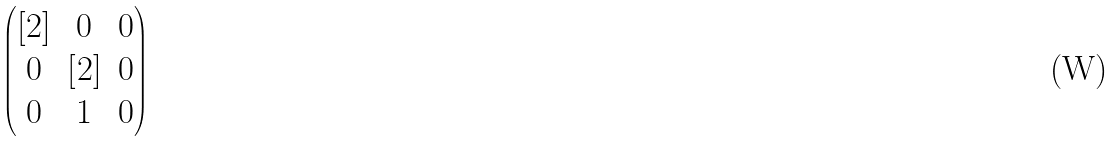Convert formula to latex. <formula><loc_0><loc_0><loc_500><loc_500>\begin{pmatrix} [ 2 ] & 0 & 0 \\ 0 & [ 2 ] & 0 \\ 0 & 1 & 0 \end{pmatrix}</formula> 